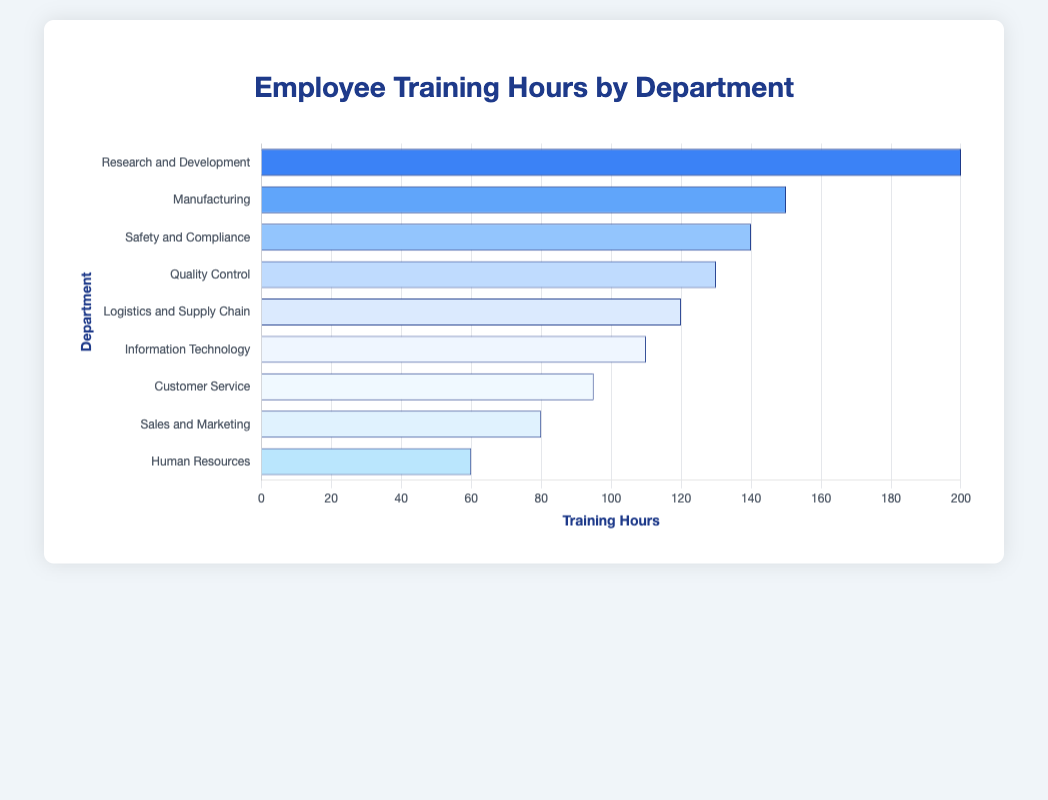What is the department with the highest training hours? To determine the department with the highest training hours, look for the tallest bar. The bar for 'Research and Development' is the tallest with 200 hours.
Answer: Research and Development Which department received 60 hours of training? Find the bar that aligns with 60 hours. The bar for 'Human Resources' matches this number.
Answer: Human Resources What is the difference in training hours between Sales and Marketing and Customer Service? Look at the training hours for both departments: Sales and Marketing (80 hours) and Customer Service (95 hours). Subtract the smaller from the larger: 95 - 80 = 15 hours.
Answer: 15 hours How many departments have training hours greater than 100? Identify bars taller than the midpoint of the x-axis, which is 100 hours. These departments are 'Research and Development', 'Manufacturing', 'Safety and Compliance', 'Quality Control', and 'Logistics and Supply Chain'. Count these bars.
Answer: 5 departments Which department has 20 hours fewer training hours than Manufacturing? Manufacturing has 150 hours. Subtract 20 to get 130 hours. The bar for 'Quality Control' shows 130 hours.
Answer: Quality Control What is the sum of the training hours for Information Technology and Logistics and Supply Chain? Add the training hours of Information Technology (110 hours) and Logistics and Supply Chain (120 hours): 110 + 120 = 230 hours.
Answer: 230 hours Which color bar represents the department with the third highest training hours? The department with the third highest training hours is 'Safety and Compliance' with 140 hours. The corresponding color for it in the bar chart is light blue.
Answer: Light Blue What is the average training hours across all departments? Add up all the training hours: 200 + 150 + 140 + 130 + 120 + 110 + 95 + 80 + 60 = 1085 hours. Divide by the number of departments, which is 9: 1085 / 9 ≈ 120.56 hours.
Answer: Approximately 120.56 hours What is the difference in training hours between the department with the highest and the lowest training hours? The department with the highest training hours is 'Research and Development' with 200 hours. The department with the lowest training hours is 'Human Resources' with 60 hours. Subtract the smaller from the larger: 200 - 60 = 140 hours.
Answer: 140 hours 